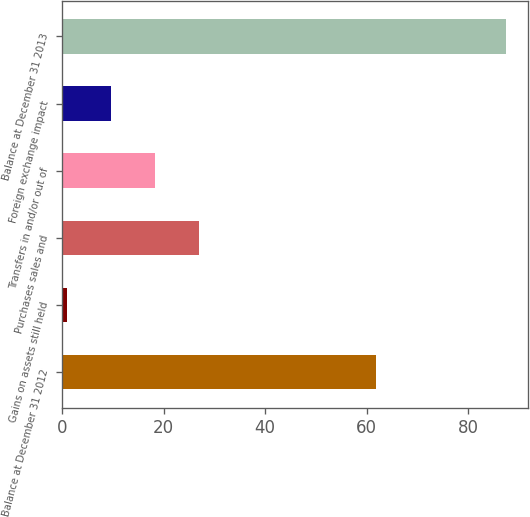<chart> <loc_0><loc_0><loc_500><loc_500><bar_chart><fcel>Balance at December 31 2012<fcel>Gains on assets still held<fcel>Purchases sales and<fcel>Transfers in and/or out of<fcel>Foreign exchange impact<fcel>Balance at December 31 2013<nl><fcel>61.8<fcel>1<fcel>26.92<fcel>18.28<fcel>9.64<fcel>87.4<nl></chart> 